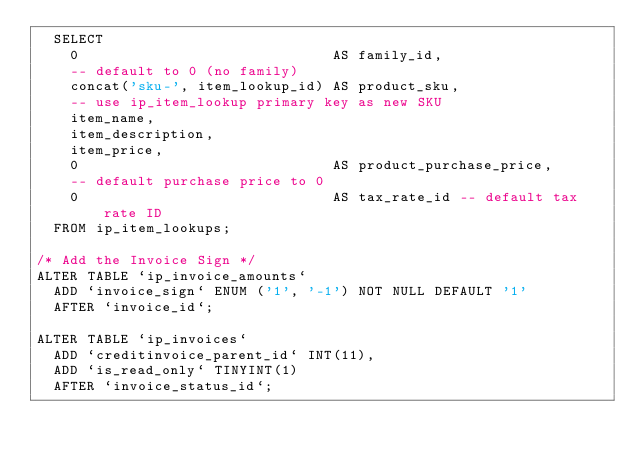Convert code to text. <code><loc_0><loc_0><loc_500><loc_500><_SQL_>  SELECT
    0                              AS family_id,
    -- default to 0 (no family)
    concat('sku-', item_lookup_id) AS product_sku,
    -- use ip_item_lookup primary key as new SKU
    item_name,
    item_description,
    item_price,
    0                              AS product_purchase_price,
    -- default purchase price to 0
    0                              AS tax_rate_id -- default tax rate ID
  FROM ip_item_lookups;

/* Add the Invoice Sign */
ALTER TABLE `ip_invoice_amounts`
  ADD `invoice_sign` ENUM ('1', '-1') NOT NULL DEFAULT '1'
  AFTER `invoice_id`;

ALTER TABLE `ip_invoices`
  ADD `creditinvoice_parent_id` INT(11),
  ADD `is_read_only` TINYINT(1)
  AFTER `invoice_status_id`;</code> 